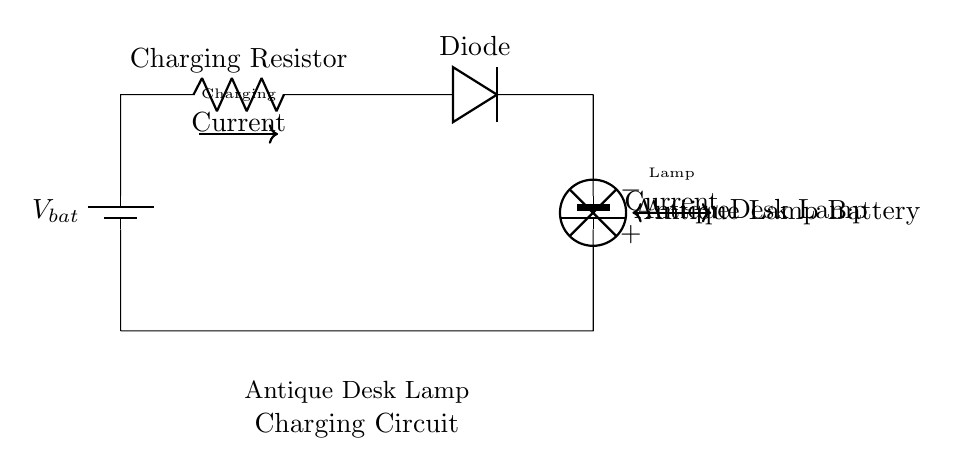What is the voltage of the battery used for charging? The voltage of the battery used for charging is indicated as Vbat in the circuit diagram. It is the first component in the circuit.
Answer: Vbat What component regulates the charging current? The charging resistor is the component that regulates the charging current within the circuit, shown directly after the battery.
Answer: Charging Resistor What type of diode is represented in this circuit? The circuit includes a diode which is used to allow current to flow in one direction, ensuring that the current flows correctly to charge the lamp's battery.
Answer: Diode How many batteries are present in the circuit? The circuit diagram shows two batteries; one is the charging battery, and the other is for the antique lamp.
Answer: Two What does the current labeled as “Charging Current” represent? The charging current represents the flow of electric charge from the charging battery through the circuit components towards the lamp's battery, which is essential for recharging it.
Answer: Charging Current Which component is used to power the antique desk lamp? The antique desk lamp is powered by the battery labeled as “Antique Lamp Battery” in the circuit, which connects to the lamp.
Answer: Antique Lamp Battery 